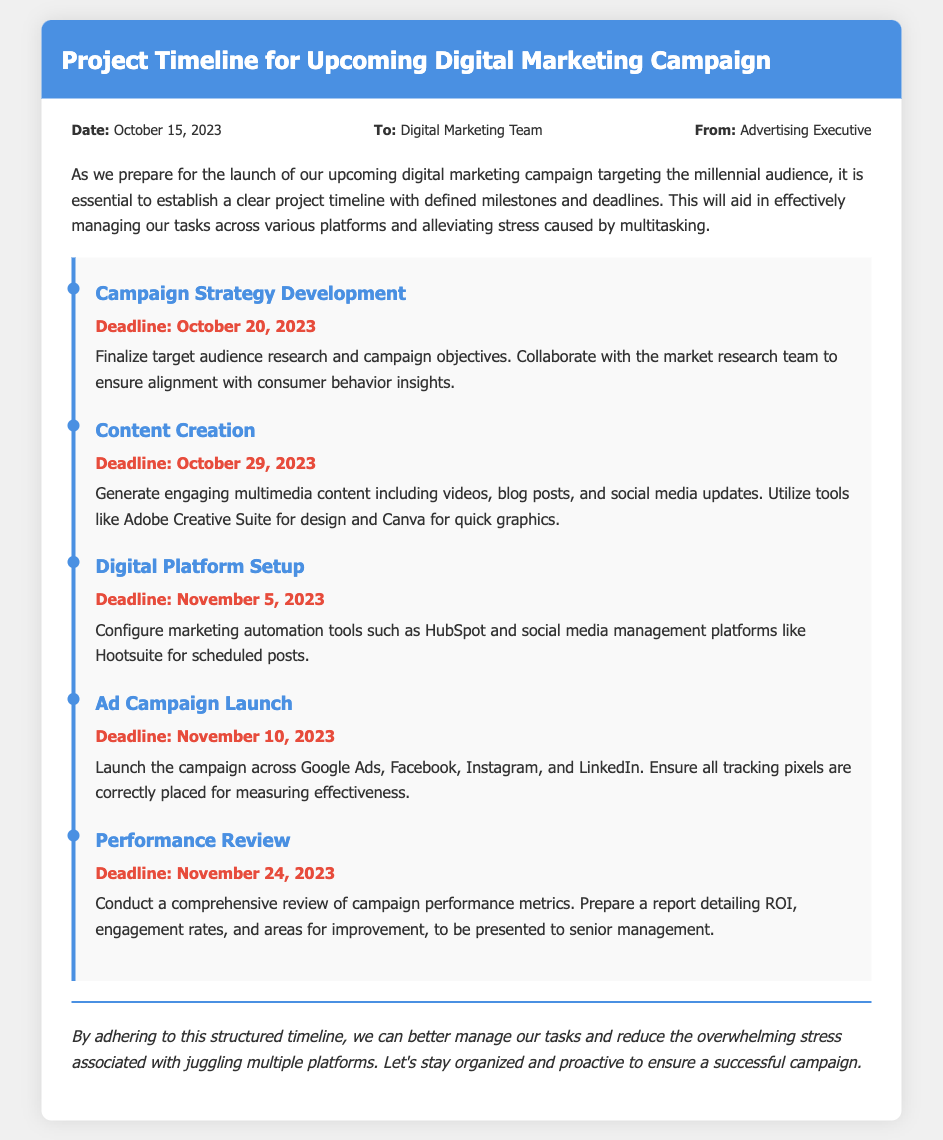what is the date of the memo? The date mentioned in the memo is the publication date which is stated at the top.
Answer: October 15, 2023 who is the memo addressed to? The memo specifies who it is intended for in the "To" section.
Answer: Digital Marketing Team what is the deadline for Campaign Strategy Development? The deadline for this milestone is indicated in the timeline section of the memo.
Answer: October 20, 2023 how many days are there until the Ad Campaign Launch from the memo date? The calculation is based on the date of the memo and the deadline for Ad Campaign Launch.
Answer: 26 days what is the purpose of the Performance Review milestone? The explanation is provided in the description under that milestone in the timeline.
Answer: To conduct a comprehensive review of campaign performance metrics what is the last milestone listed in the document? The last milestone mentioned is at the end of the timeline section.
Answer: Performance Review which tools are suggested for digital platform setup? The tools used for this setup are specified in the respective milestone description.
Answer: HubSpot and Hootsuite what is emphasized as a benefit of adhering to the timeline? The closing paragraph points out the main benefit of following the timeline.
Answer: Reduce overwhelming stress 